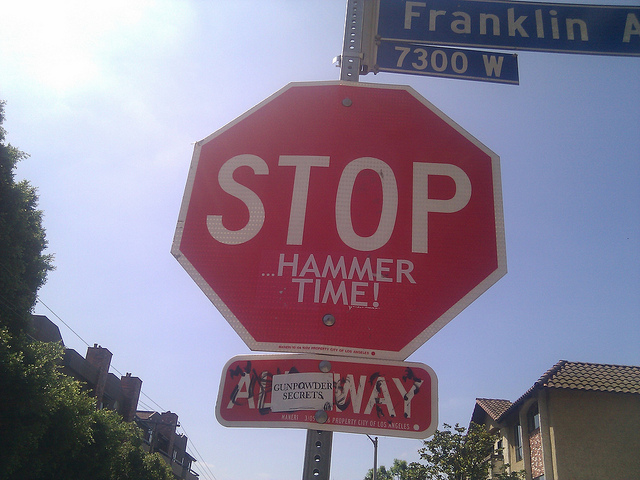Identify the text contained in this image. Franklin 7300 W HAMMER TIME A SECRETS CUNPOWDER STOP 